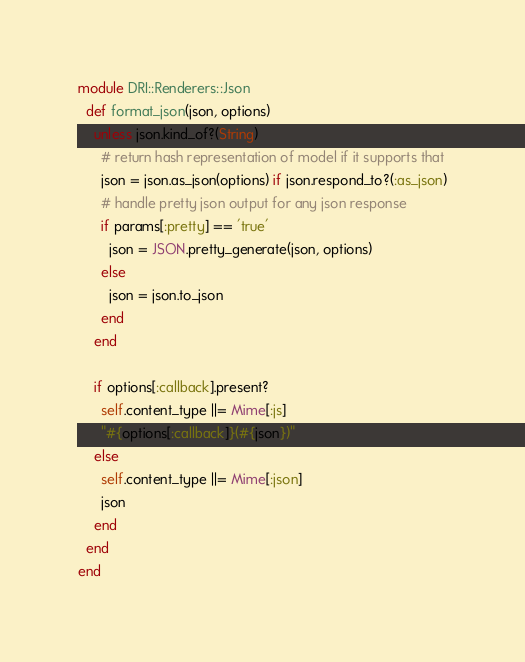<code> <loc_0><loc_0><loc_500><loc_500><_Ruby_>module DRI::Renderers::Json
  def format_json(json, options)
    unless json.kind_of?(String)
      # return hash representation of model if it supports that
      json = json.as_json(options) if json.respond_to?(:as_json)
      # handle pretty json output for any json response
      if params[:pretty] == 'true'
        json = JSON.pretty_generate(json, options)
      else
        json = json.to_json
      end
    end

    if options[:callback].present?
      self.content_type ||= Mime[:js]
      "#{options[:callback]}(#{json})"
    else
      self.content_type ||= Mime[:json]
      json
    end
  end
end
</code> 